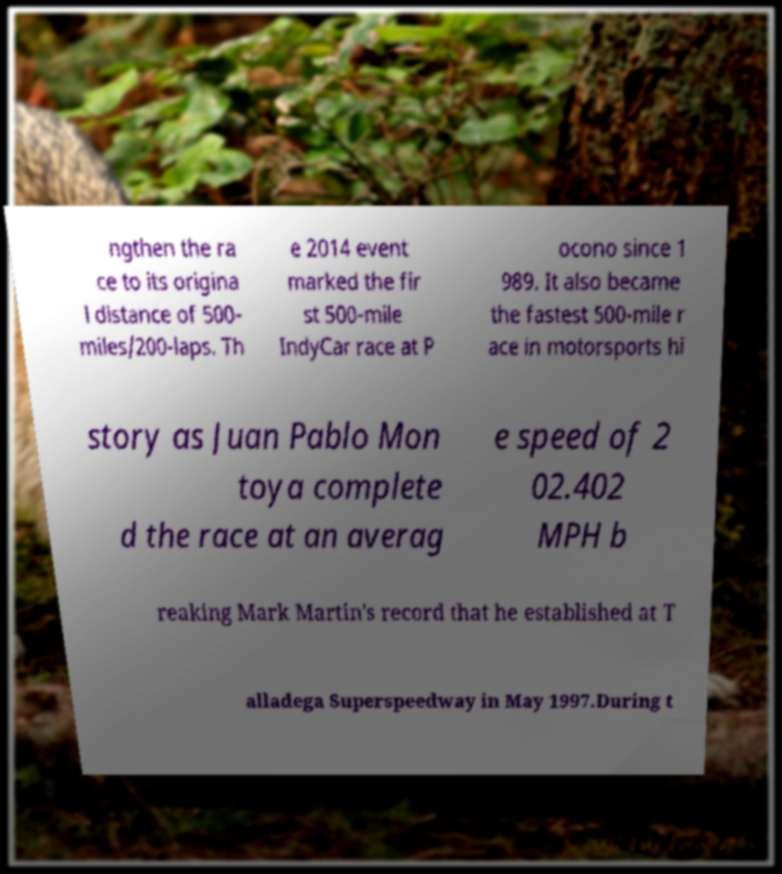Could you assist in decoding the text presented in this image and type it out clearly? ngthen the ra ce to its origina l distance of 500- miles/200-laps. Th e 2014 event marked the fir st 500-mile IndyCar race at P ocono since 1 989. It also became the fastest 500-mile r ace in motorsports hi story as Juan Pablo Mon toya complete d the race at an averag e speed of 2 02.402 MPH b reaking Mark Martin's record that he established at T alladega Superspeedway in May 1997.During t 